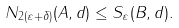Convert formula to latex. <formula><loc_0><loc_0><loc_500><loc_500>N _ { 2 ( \varepsilon + \delta ) } ( A , d ) \leq S _ { \varepsilon } ( B , d ) .</formula> 